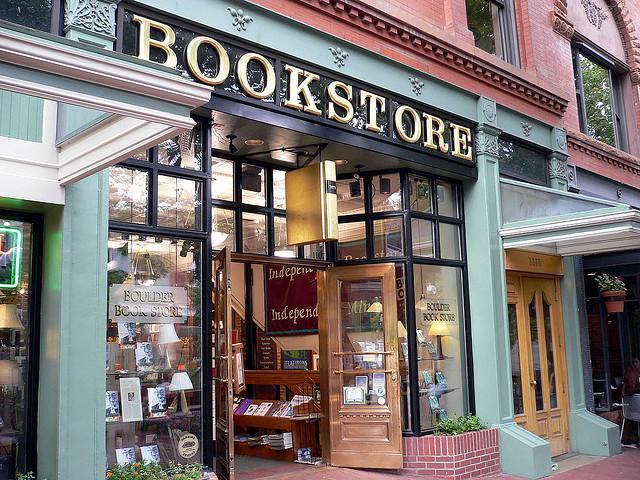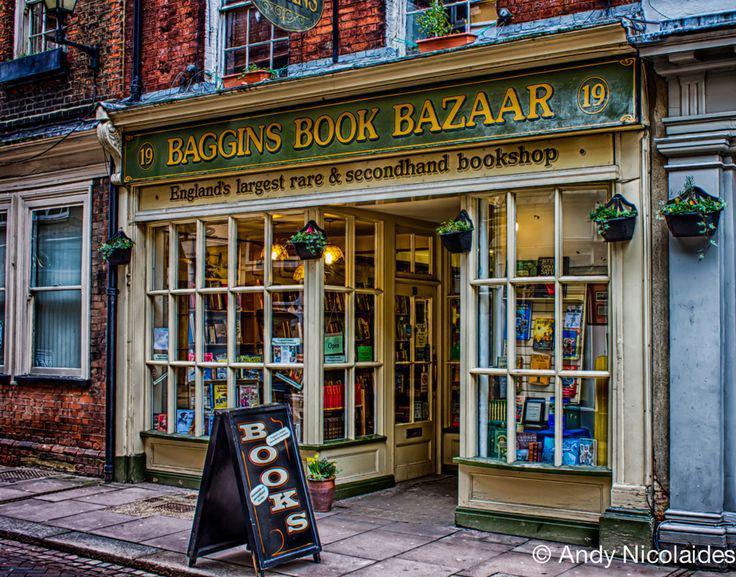The first image is the image on the left, the second image is the image on the right. Assess this claim about the two images: "In one image a bookstore with its entrance located between two large window areas has at least one advertising placard on the sidewalk in front.". Correct or not? Answer yes or no. Yes. 